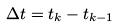<formula> <loc_0><loc_0><loc_500><loc_500>\Delta t = t _ { k } - t _ { k - 1 }</formula> 